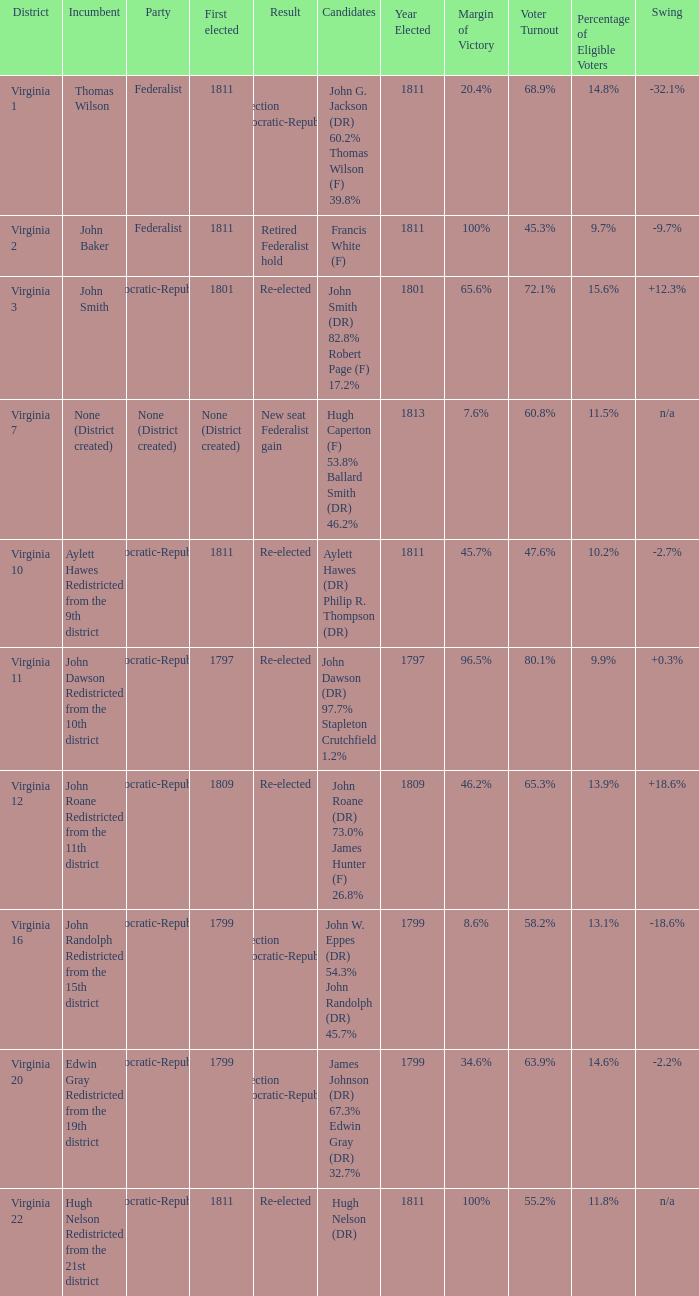Name the party for  john randolph redistricted from the 15th district Democratic-Republican. 